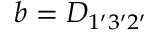<formula> <loc_0><loc_0><loc_500><loc_500>b = { D } _ { 1 ^ { \prime } 3 ^ { \prime } 2 ^ { \prime } }</formula> 